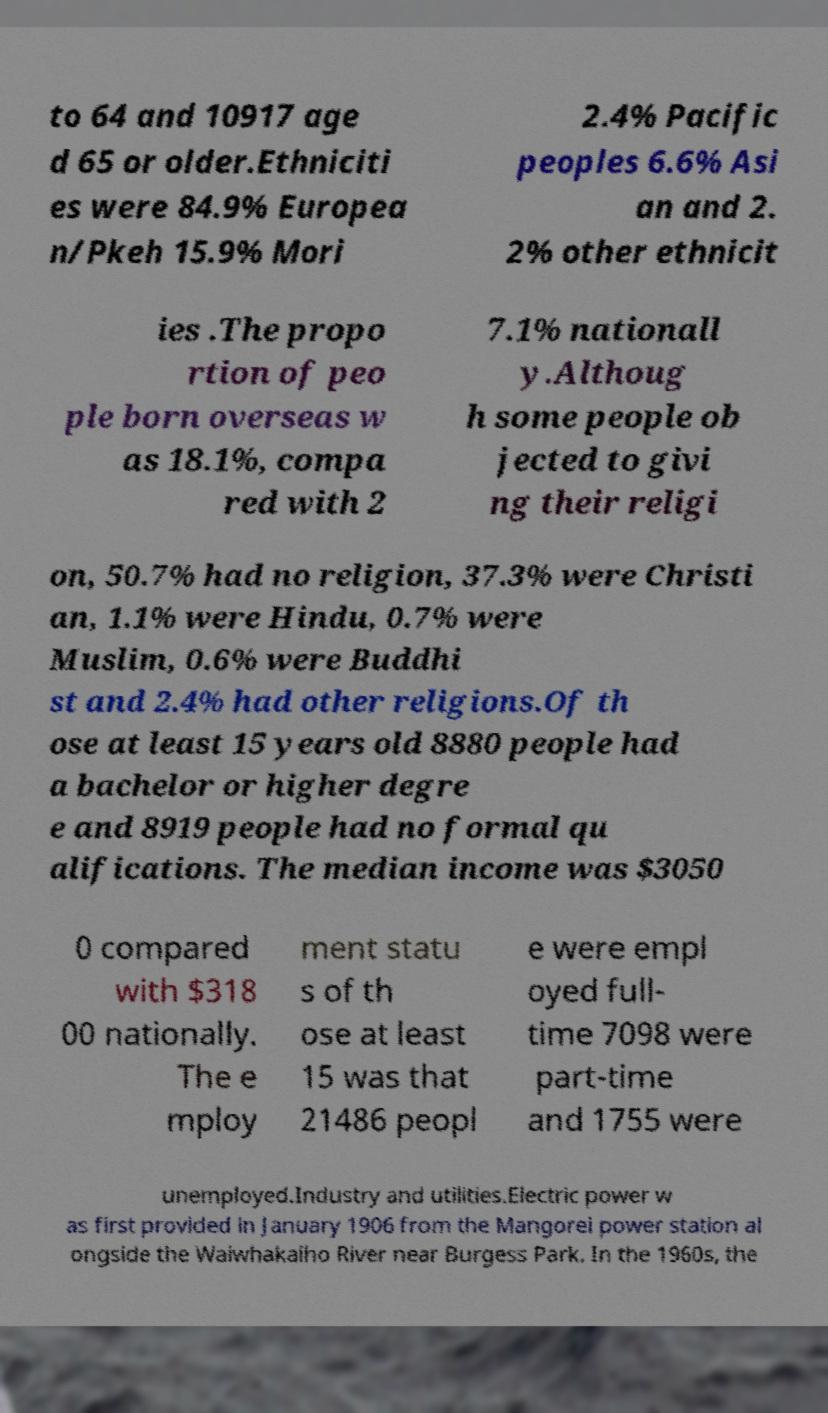Could you extract and type out the text from this image? to 64 and 10917 age d 65 or older.Ethniciti es were 84.9% Europea n/Pkeh 15.9% Mori 2.4% Pacific peoples 6.6% Asi an and 2. 2% other ethnicit ies .The propo rtion of peo ple born overseas w as 18.1%, compa red with 2 7.1% nationall y.Althoug h some people ob jected to givi ng their religi on, 50.7% had no religion, 37.3% were Christi an, 1.1% were Hindu, 0.7% were Muslim, 0.6% were Buddhi st and 2.4% had other religions.Of th ose at least 15 years old 8880 people had a bachelor or higher degre e and 8919 people had no formal qu alifications. The median income was $3050 0 compared with $318 00 nationally. The e mploy ment statu s of th ose at least 15 was that 21486 peopl e were empl oyed full- time 7098 were part-time and 1755 were unemployed.Industry and utilities.Electric power w as first provided in January 1906 from the Mangorei power station al ongside the Waiwhakaiho River near Burgess Park. In the 1960s, the 